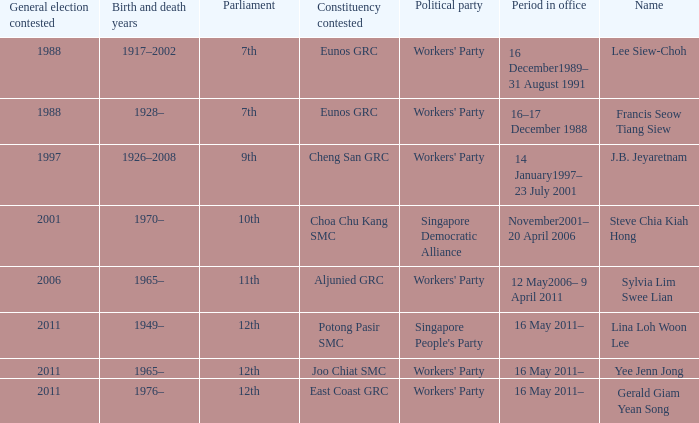Which parliament is sylvia lim swee lian? 11th. Could you help me parse every detail presented in this table? {'header': ['General election contested', 'Birth and death years', 'Parliament', 'Constituency contested', 'Political party', 'Period in office', 'Name'], 'rows': [['1988', '1917–2002', '7th', 'Eunos GRC', "Workers' Party", '16 December1989– 31 August 1991', 'Lee Siew-Choh'], ['1988', '1928–', '7th', 'Eunos GRC', "Workers' Party", '16–17 December 1988', 'Francis Seow Tiang Siew'], ['1997', '1926–2008', '9th', 'Cheng San GRC', "Workers' Party", '14 January1997– 23 July 2001', 'J.B. Jeyaretnam'], ['2001', '1970–', '10th', 'Choa Chu Kang SMC', 'Singapore Democratic Alliance', 'November2001– 20 April 2006', 'Steve Chia Kiah Hong'], ['2006', '1965–', '11th', 'Aljunied GRC', "Workers' Party", '12 May2006– 9 April 2011', 'Sylvia Lim Swee Lian'], ['2011', '1949–', '12th', 'Potong Pasir SMC', "Singapore People's Party", '16 May 2011–', 'Lina Loh Woon Lee'], ['2011', '1965–', '12th', 'Joo Chiat SMC', "Workers' Party", '16 May 2011–', 'Yee Jenn Jong'], ['2011', '1976–', '12th', 'East Coast GRC', "Workers' Party", '16 May 2011–', 'Gerald Giam Yean Song']]} 